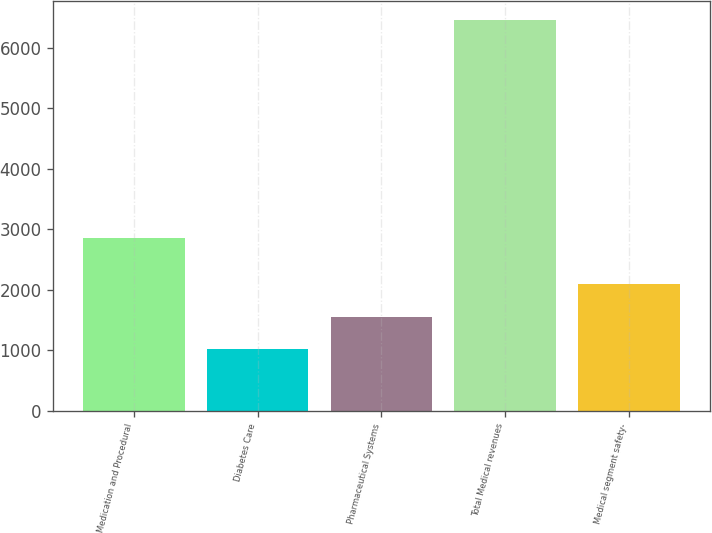Convert chart to OTSL. <chart><loc_0><loc_0><loc_500><loc_500><bar_chart><fcel>Medication and Procedural<fcel>Diabetes Care<fcel>Pharmaceutical Systems<fcel>Total Medical revenues<fcel>Medical segment safety-<nl><fcel>2850<fcel>1012<fcel>1556.8<fcel>6460<fcel>2101.6<nl></chart> 